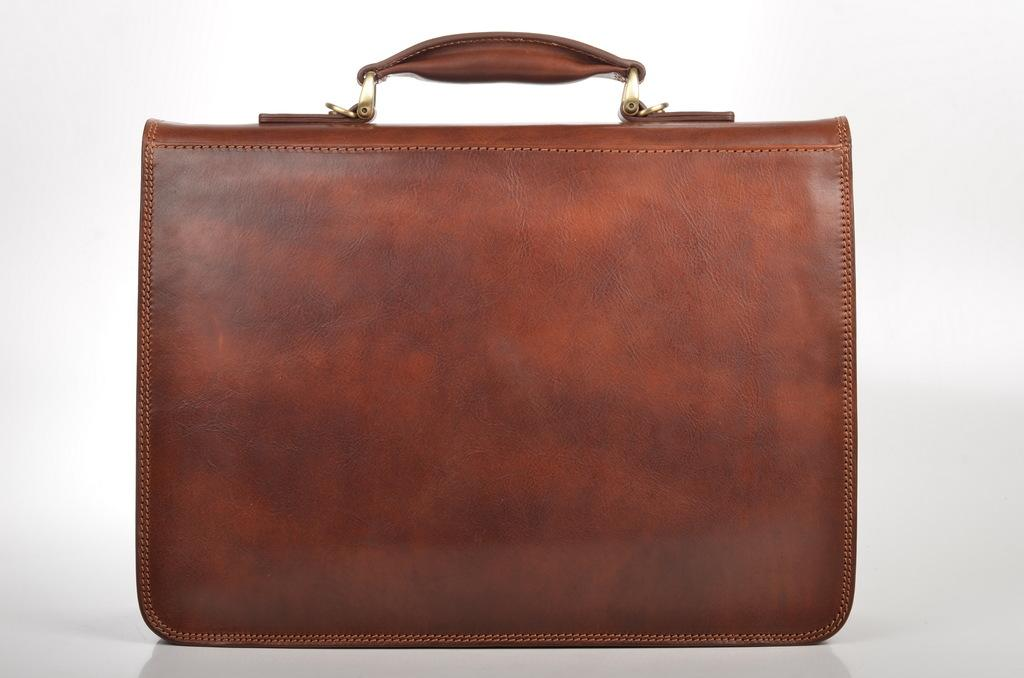What type of bag is visible in the image? There is a brown bag in the image. What type of crayon can be seen inside the brown bag in the image? There is no crayon visible in the image, as it only shows a brown bag. 